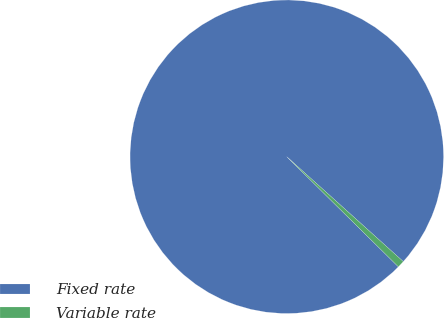<chart> <loc_0><loc_0><loc_500><loc_500><pie_chart><fcel>Fixed rate<fcel>Variable rate<nl><fcel>99.27%<fcel>0.73%<nl></chart> 